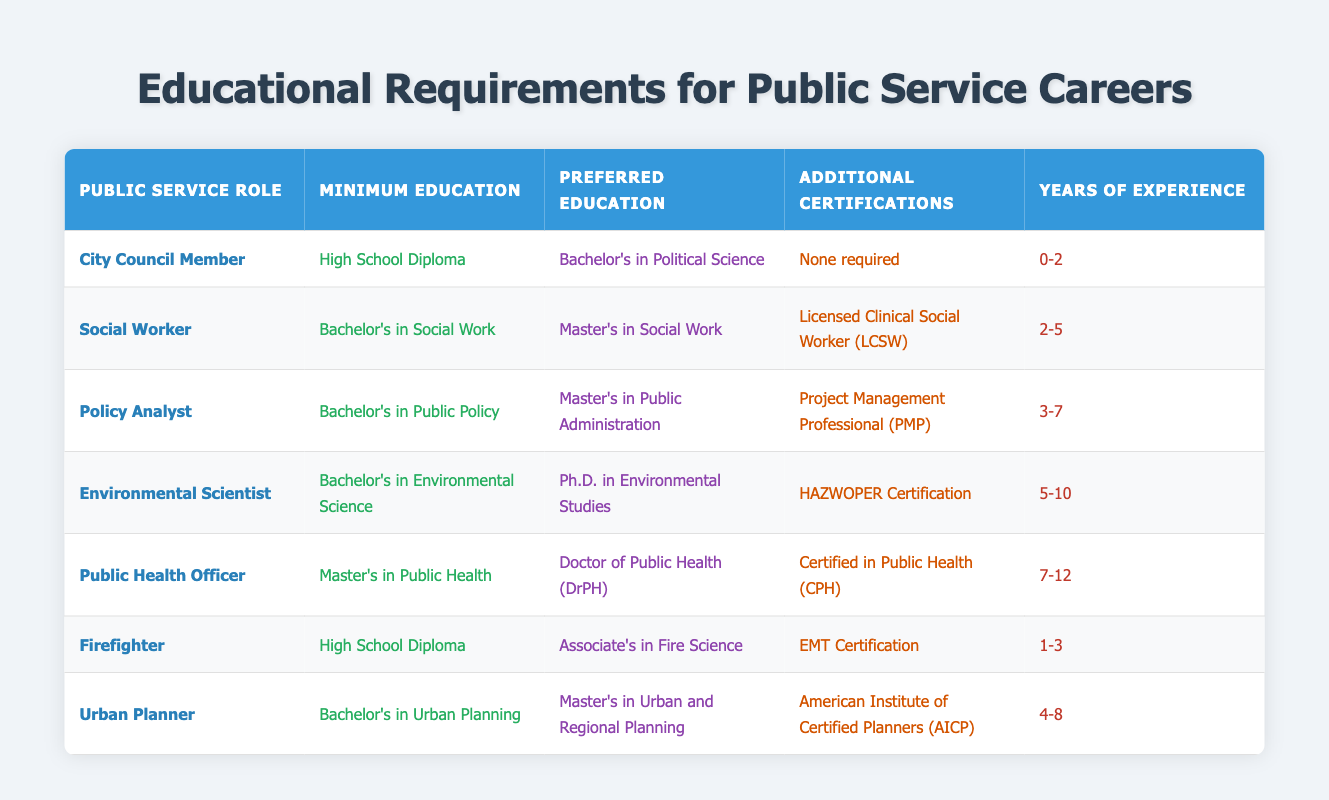What is the minimum education required for a Policy Analyst? According to the table, the minimum education required for a Policy Analyst is a Bachelor's in Public Policy. This value can be found in the corresponding row for the Policy Analyst role under the "Minimum Education" column.
Answer: Bachelor's in Public Policy Which public service role requires the highest preferred education? Looking through the table, the Public Health Officer requires the Doctor of Public Health (DrPH) as the preferred education, which is a higher level compared to the other roles listed. This can be confirmed by comparing the "Preferred Education" column across all roles.
Answer: Public Health Officer How many total years of experience are required for a Social Worker and Urban Planner combined? The years of experience required for a Social Worker is 2-5 years and for an Urban Planner is 4-8 years. To find the total range of experience, we can combine their minimums and maximums: Minimum total experience = 2 + 4 = 6 years; Maximum total experience = 5 + 8 = 13 years. Thus, the combined range is 6-13 years.
Answer: 6-13 years Is it true that all public service roles require a minimum of some college education? Examining the table, the City Council Member and Firefighter roles both only require a High School Diploma as their minimum education. This indicates that not all roles necessitate any form of college education, rendering the statement false.
Answer: False Which roles require additional certifications, and how many? By reviewing the table, the roles that require additional certifications are Social Worker (Licensed Clinical Social Worker), Policy Analyst (Project Management Professional), Environmental Scientist (HAZWOPER Certification), Public Health Officer (Certified in Public Health), and Firefighter (EMT Certification). In total, 5 roles require additional certifications.
Answer: 5 roles 